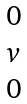Convert formula to latex. <formula><loc_0><loc_0><loc_500><loc_500>\begin{matrix} 0 \\ v \\ 0 \\ \end{matrix}</formula> 